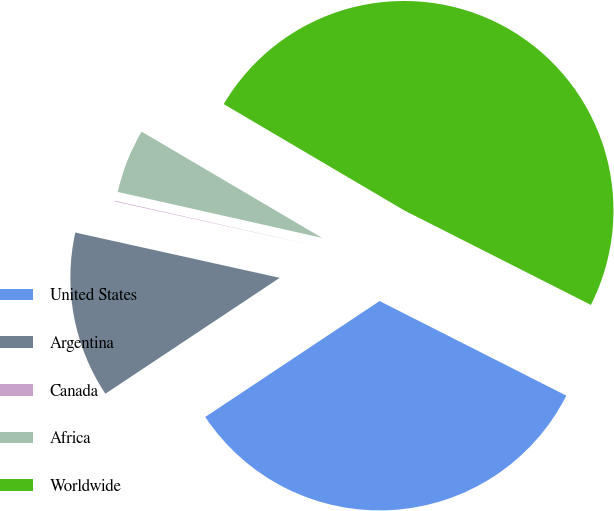Convert chart. <chart><loc_0><loc_0><loc_500><loc_500><pie_chart><fcel>United States<fcel>Argentina<fcel>Canada<fcel>Africa<fcel>Worldwide<nl><fcel>33.2%<fcel>12.81%<fcel>0.05%<fcel>4.95%<fcel>48.99%<nl></chart> 